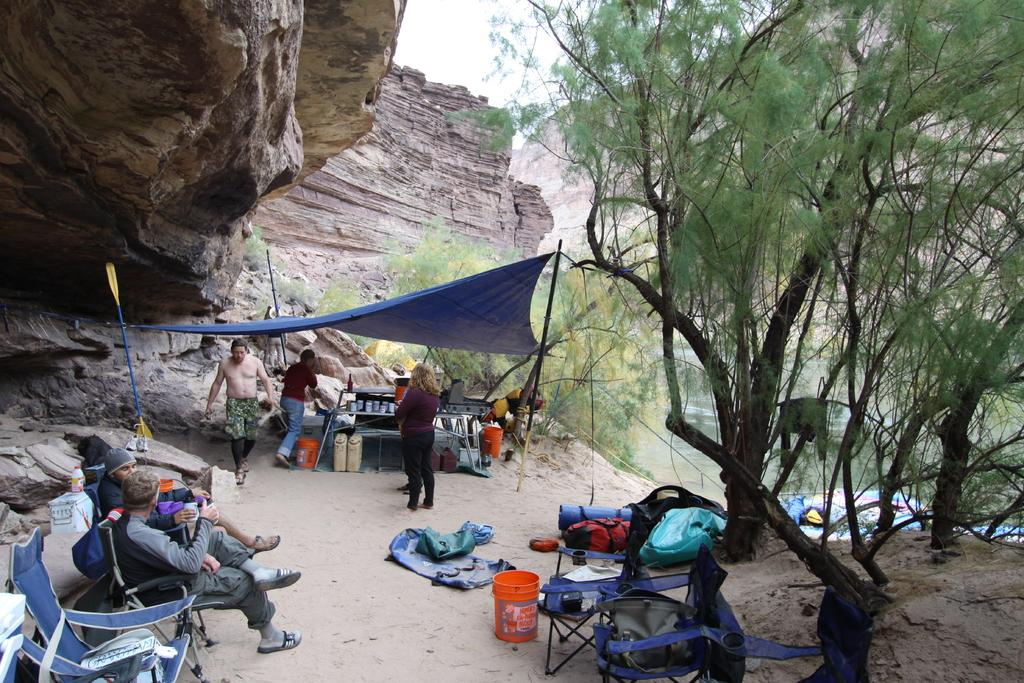How many people are sitting on chairs in the image? There are two persons sitting on chairs on the left side of the image. What structure is located in the middle of the image? There is a tent in the middle of the image. What is the man in the image doing? A man is walking in the image. What type of vegetation is on the right side of the image? There are trees on the right side of the image. What natural element is visible in the image? There is water visible in the image. What type of guitar can be seen hanging from the trees on the right side of the image? There is no guitar present in the image; it only features two persons sitting on chairs, a tent, a walking man, trees, and water. Is there a metal sculpture visible in the image? There is no metal sculpture present in the image. 